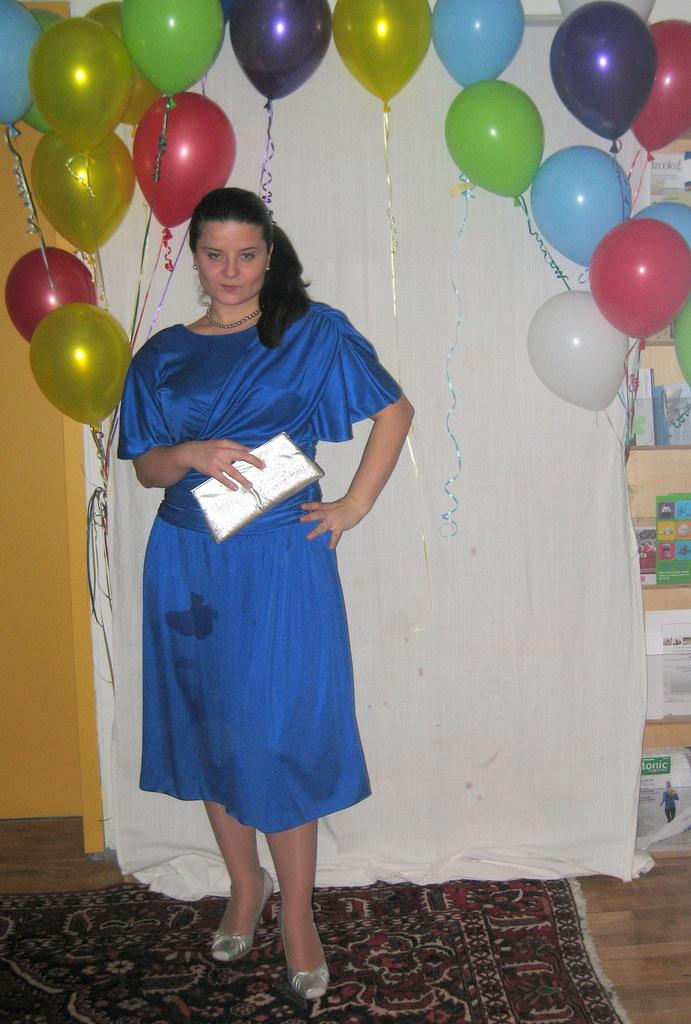What is the appearance of the woman in the image? There is a beautiful woman in the image. What is the woman doing in the image? The woman is standing. What color is the dress the woman is wearing? The woman is wearing a blue dress. What can be seen behind the woman in the image? There are balloons behind the woman. What type of needle is the woman using to sew the balloons in the image? There is no needle or sewing activity present in the image. Who is the manager of the woman in the image? The image does not provide any information about a manager or any professional relationship. 